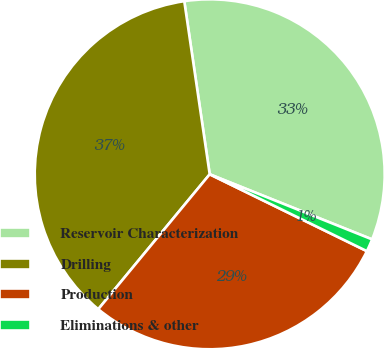Convert chart to OTSL. <chart><loc_0><loc_0><loc_500><loc_500><pie_chart><fcel>Reservoir Characterization<fcel>Drilling<fcel>Production<fcel>Eliminations & other<nl><fcel>33.39%<fcel>36.69%<fcel>28.75%<fcel>1.17%<nl></chart> 